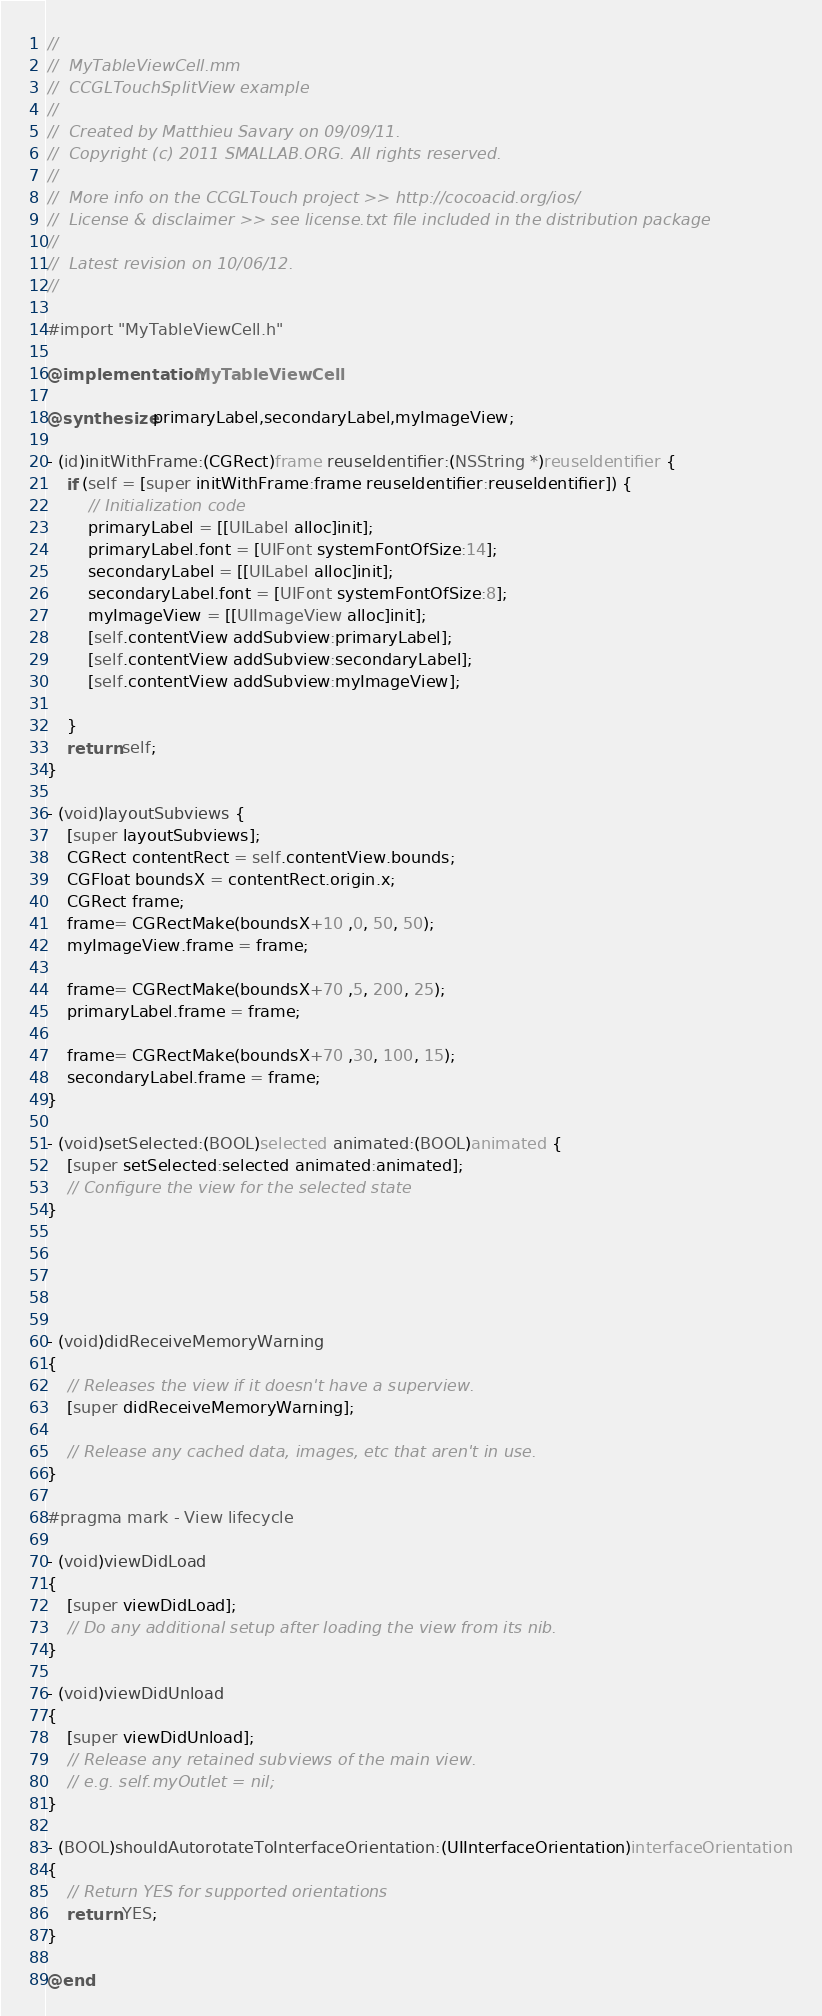<code> <loc_0><loc_0><loc_500><loc_500><_ObjectiveC_>//
//  MyTableViewCell.mm
//  CCGLTouchSplitView example
//
//  Created by Matthieu Savary on 09/09/11.
//  Copyright (c) 2011 SMALLAB.ORG. All rights reserved.
//
//  More info on the CCGLTouch project >> http://cocoacid.org/ios/
//  License & disclaimer >> see license.txt file included in the distribution package
//
//  Latest revision on 10/06/12.
//

#import "MyTableViewCell.h"

@implementation MyTableViewCell

@synthesize primaryLabel,secondaryLabel,myImageView;

- (id)initWithFrame:(CGRect)frame reuseIdentifier:(NSString *)reuseIdentifier {
    if (self = [super initWithFrame:frame reuseIdentifier:reuseIdentifier]) {
        // Initialization code
        primaryLabel = [[UILabel alloc]init];
        primaryLabel.font = [UIFont systemFontOfSize:14];
        secondaryLabel = [[UILabel alloc]init];
        secondaryLabel.font = [UIFont systemFontOfSize:8];
        myImageView = [[UIImageView alloc]init];
        [self.contentView addSubview:primaryLabel];
        [self.contentView addSubview:secondaryLabel];
        [self.contentView addSubview:myImageView];
        
    }
    return self;
}

- (void)layoutSubviews {
    [super layoutSubviews];
    CGRect contentRect = self.contentView.bounds;
    CGFloat boundsX = contentRect.origin.x;
    CGRect frame;
    frame= CGRectMake(boundsX+10 ,0, 50, 50);
    myImageView.frame = frame;
    
    frame= CGRectMake(boundsX+70 ,5, 200, 25);
    primaryLabel.frame = frame;
    
    frame= CGRectMake(boundsX+70 ,30, 100, 15);
    secondaryLabel.frame = frame;
}

- (void)setSelected:(BOOL)selected animated:(BOOL)animated {
    [super setSelected:selected animated:animated];
    // Configure the view for the selected state
}





- (void)didReceiveMemoryWarning
{
    // Releases the view if it doesn't have a superview.
    [super didReceiveMemoryWarning];
    
    // Release any cached data, images, etc that aren't in use.
}

#pragma mark - View lifecycle

- (void)viewDidLoad
{
    [super viewDidLoad];
    // Do any additional setup after loading the view from its nib.
}

- (void)viewDidUnload
{
    [super viewDidUnload];
    // Release any retained subviews of the main view.
    // e.g. self.myOutlet = nil;
}

- (BOOL)shouldAutorotateToInterfaceOrientation:(UIInterfaceOrientation)interfaceOrientation
{
    // Return YES for supported orientations
	return YES;
}

@end
</code> 